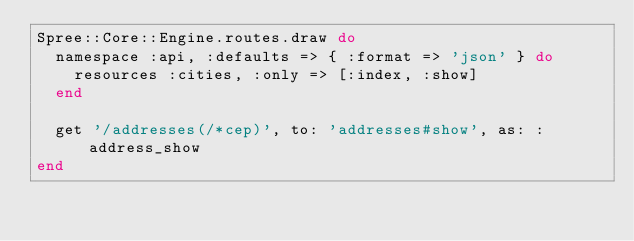Convert code to text. <code><loc_0><loc_0><loc_500><loc_500><_Ruby_>Spree::Core::Engine.routes.draw do
  namespace :api, :defaults => { :format => 'json' } do
    resources :cities, :only => [:index, :show]
  end

  get '/addresses(/*cep)', to: 'addresses#show', as: :address_show
end
</code> 